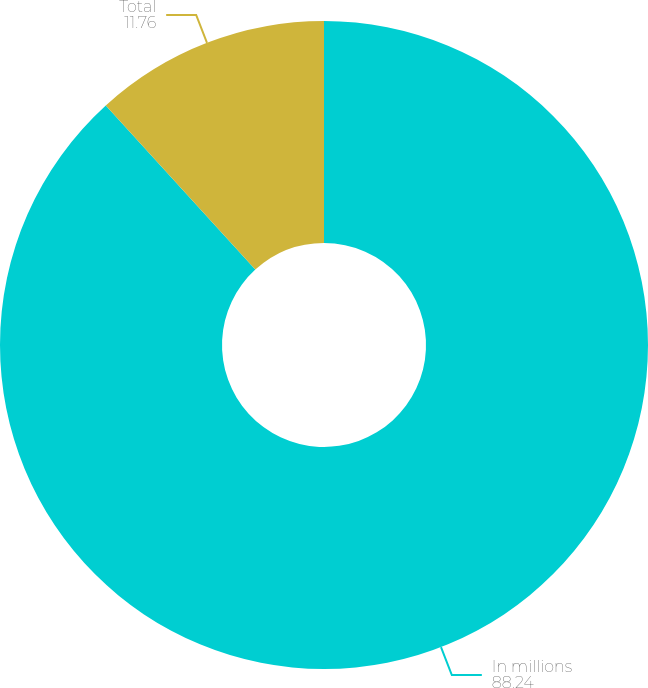Convert chart to OTSL. <chart><loc_0><loc_0><loc_500><loc_500><pie_chart><fcel>In millions<fcel>Total<nl><fcel>88.24%<fcel>11.76%<nl></chart> 